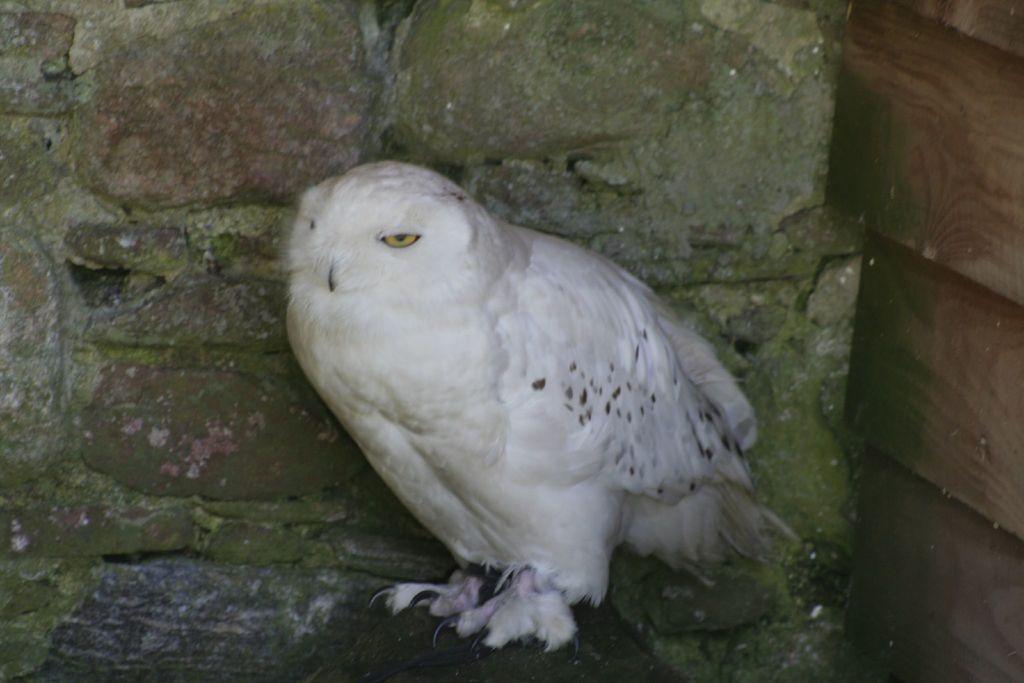How would you summarize this image in a sentence or two? In this image I can see an owl which is white and black in color is standing in the rock and in the background I can see the wooden surface which is brown and green in color and the wall which is made up of rocks. 